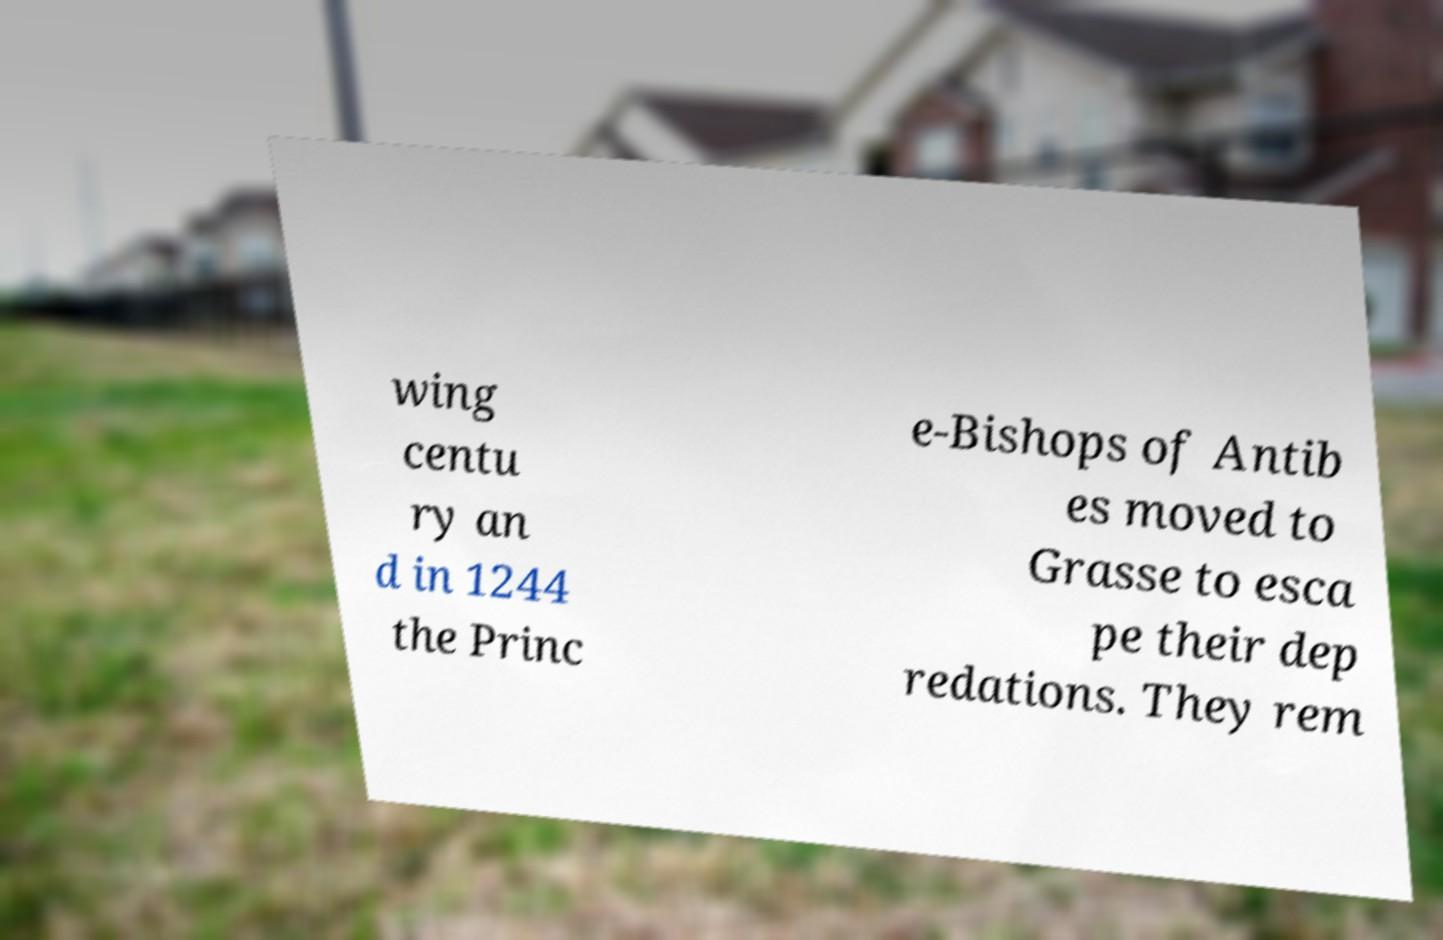There's text embedded in this image that I need extracted. Can you transcribe it verbatim? wing centu ry an d in 1244 the Princ e-Bishops of Antib es moved to Grasse to esca pe their dep redations. They rem 